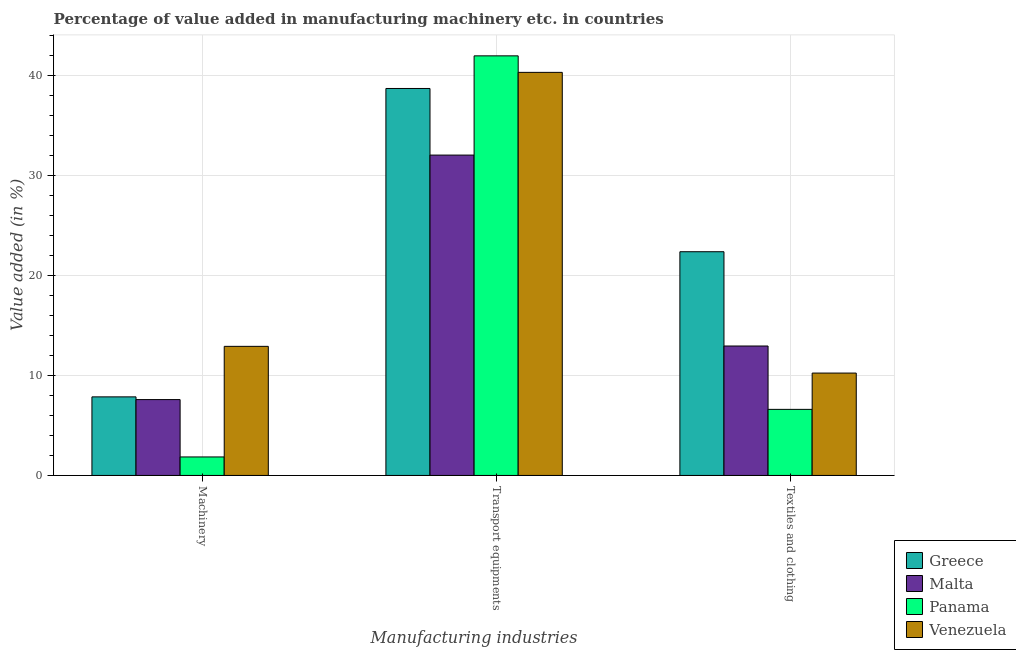How many groups of bars are there?
Keep it short and to the point. 3. Are the number of bars per tick equal to the number of legend labels?
Make the answer very short. Yes. Are the number of bars on each tick of the X-axis equal?
Your answer should be very brief. Yes. How many bars are there on the 3rd tick from the left?
Provide a short and direct response. 4. What is the label of the 2nd group of bars from the left?
Make the answer very short. Transport equipments. What is the value added in manufacturing transport equipments in Malta?
Your answer should be very brief. 32.06. Across all countries, what is the maximum value added in manufacturing machinery?
Your answer should be very brief. 12.92. Across all countries, what is the minimum value added in manufacturing transport equipments?
Give a very brief answer. 32.06. In which country was the value added in manufacturing transport equipments maximum?
Give a very brief answer. Panama. In which country was the value added in manufacturing machinery minimum?
Provide a short and direct response. Panama. What is the total value added in manufacturing machinery in the graph?
Keep it short and to the point. 30.22. What is the difference between the value added in manufacturing textile and clothing in Venezuela and that in Panama?
Give a very brief answer. 3.63. What is the difference between the value added in manufacturing textile and clothing in Venezuela and the value added in manufacturing transport equipments in Panama?
Your answer should be compact. -31.74. What is the average value added in manufacturing textile and clothing per country?
Ensure brevity in your answer.  13.05. What is the difference between the value added in manufacturing textile and clothing and value added in manufacturing transport equipments in Venezuela?
Your answer should be compact. -30.09. In how many countries, is the value added in manufacturing transport equipments greater than 26 %?
Ensure brevity in your answer.  4. What is the ratio of the value added in manufacturing textile and clothing in Greece to that in Venezuela?
Keep it short and to the point. 2.19. What is the difference between the highest and the second highest value added in manufacturing machinery?
Provide a short and direct response. 5.05. What is the difference between the highest and the lowest value added in manufacturing textile and clothing?
Your answer should be very brief. 15.78. What does the 4th bar from the left in Transport equipments represents?
Give a very brief answer. Venezuela. What does the 3rd bar from the right in Transport equipments represents?
Your answer should be compact. Malta. Are the values on the major ticks of Y-axis written in scientific E-notation?
Offer a very short reply. No. Does the graph contain any zero values?
Make the answer very short. No. How are the legend labels stacked?
Your answer should be compact. Vertical. What is the title of the graph?
Offer a terse response. Percentage of value added in manufacturing machinery etc. in countries. Does "Niger" appear as one of the legend labels in the graph?
Offer a terse response. No. What is the label or title of the X-axis?
Ensure brevity in your answer.  Manufacturing industries. What is the label or title of the Y-axis?
Give a very brief answer. Value added (in %). What is the Value added (in %) in Greece in Machinery?
Ensure brevity in your answer.  7.86. What is the Value added (in %) in Malta in Machinery?
Ensure brevity in your answer.  7.59. What is the Value added (in %) in Panama in Machinery?
Your response must be concise. 1.85. What is the Value added (in %) of Venezuela in Machinery?
Your response must be concise. 12.92. What is the Value added (in %) of Greece in Transport equipments?
Keep it short and to the point. 38.72. What is the Value added (in %) in Malta in Transport equipments?
Make the answer very short. 32.06. What is the Value added (in %) of Panama in Transport equipments?
Your response must be concise. 41.99. What is the Value added (in %) in Venezuela in Transport equipments?
Offer a terse response. 40.33. What is the Value added (in %) in Greece in Textiles and clothing?
Your response must be concise. 22.39. What is the Value added (in %) of Malta in Textiles and clothing?
Offer a very short reply. 12.95. What is the Value added (in %) of Panama in Textiles and clothing?
Make the answer very short. 6.61. What is the Value added (in %) of Venezuela in Textiles and clothing?
Your response must be concise. 10.24. Across all Manufacturing industries, what is the maximum Value added (in %) of Greece?
Give a very brief answer. 38.72. Across all Manufacturing industries, what is the maximum Value added (in %) in Malta?
Give a very brief answer. 32.06. Across all Manufacturing industries, what is the maximum Value added (in %) in Panama?
Provide a succinct answer. 41.99. Across all Manufacturing industries, what is the maximum Value added (in %) of Venezuela?
Make the answer very short. 40.33. Across all Manufacturing industries, what is the minimum Value added (in %) in Greece?
Your answer should be compact. 7.86. Across all Manufacturing industries, what is the minimum Value added (in %) of Malta?
Give a very brief answer. 7.59. Across all Manufacturing industries, what is the minimum Value added (in %) in Panama?
Provide a short and direct response. 1.85. Across all Manufacturing industries, what is the minimum Value added (in %) of Venezuela?
Offer a very short reply. 10.24. What is the total Value added (in %) in Greece in the graph?
Offer a very short reply. 68.97. What is the total Value added (in %) in Malta in the graph?
Provide a short and direct response. 52.6. What is the total Value added (in %) in Panama in the graph?
Your answer should be compact. 50.45. What is the total Value added (in %) of Venezuela in the graph?
Make the answer very short. 63.49. What is the difference between the Value added (in %) in Greece in Machinery and that in Transport equipments?
Provide a succinct answer. -30.86. What is the difference between the Value added (in %) in Malta in Machinery and that in Transport equipments?
Give a very brief answer. -24.47. What is the difference between the Value added (in %) in Panama in Machinery and that in Transport equipments?
Offer a terse response. -40.14. What is the difference between the Value added (in %) of Venezuela in Machinery and that in Transport equipments?
Offer a terse response. -27.42. What is the difference between the Value added (in %) of Greece in Machinery and that in Textiles and clothing?
Keep it short and to the point. -14.52. What is the difference between the Value added (in %) of Malta in Machinery and that in Textiles and clothing?
Provide a succinct answer. -5.36. What is the difference between the Value added (in %) of Panama in Machinery and that in Textiles and clothing?
Make the answer very short. -4.76. What is the difference between the Value added (in %) of Venezuela in Machinery and that in Textiles and clothing?
Provide a short and direct response. 2.67. What is the difference between the Value added (in %) of Greece in Transport equipments and that in Textiles and clothing?
Provide a short and direct response. 16.34. What is the difference between the Value added (in %) in Malta in Transport equipments and that in Textiles and clothing?
Your response must be concise. 19.1. What is the difference between the Value added (in %) in Panama in Transport equipments and that in Textiles and clothing?
Provide a succinct answer. 35.38. What is the difference between the Value added (in %) of Venezuela in Transport equipments and that in Textiles and clothing?
Give a very brief answer. 30.09. What is the difference between the Value added (in %) of Greece in Machinery and the Value added (in %) of Malta in Transport equipments?
Make the answer very short. -24.19. What is the difference between the Value added (in %) of Greece in Machinery and the Value added (in %) of Panama in Transport equipments?
Your answer should be very brief. -34.12. What is the difference between the Value added (in %) in Greece in Machinery and the Value added (in %) in Venezuela in Transport equipments?
Provide a succinct answer. -32.47. What is the difference between the Value added (in %) in Malta in Machinery and the Value added (in %) in Panama in Transport equipments?
Your answer should be very brief. -34.4. What is the difference between the Value added (in %) in Malta in Machinery and the Value added (in %) in Venezuela in Transport equipments?
Make the answer very short. -32.74. What is the difference between the Value added (in %) in Panama in Machinery and the Value added (in %) in Venezuela in Transport equipments?
Your answer should be very brief. -38.48. What is the difference between the Value added (in %) in Greece in Machinery and the Value added (in %) in Malta in Textiles and clothing?
Keep it short and to the point. -5.09. What is the difference between the Value added (in %) in Greece in Machinery and the Value added (in %) in Panama in Textiles and clothing?
Your answer should be very brief. 1.25. What is the difference between the Value added (in %) in Greece in Machinery and the Value added (in %) in Venezuela in Textiles and clothing?
Give a very brief answer. -2.38. What is the difference between the Value added (in %) in Malta in Machinery and the Value added (in %) in Panama in Textiles and clothing?
Keep it short and to the point. 0.98. What is the difference between the Value added (in %) in Malta in Machinery and the Value added (in %) in Venezuela in Textiles and clothing?
Your answer should be very brief. -2.65. What is the difference between the Value added (in %) of Panama in Machinery and the Value added (in %) of Venezuela in Textiles and clothing?
Offer a very short reply. -8.39. What is the difference between the Value added (in %) in Greece in Transport equipments and the Value added (in %) in Malta in Textiles and clothing?
Ensure brevity in your answer.  25.77. What is the difference between the Value added (in %) in Greece in Transport equipments and the Value added (in %) in Panama in Textiles and clothing?
Make the answer very short. 32.11. What is the difference between the Value added (in %) in Greece in Transport equipments and the Value added (in %) in Venezuela in Textiles and clothing?
Make the answer very short. 28.48. What is the difference between the Value added (in %) in Malta in Transport equipments and the Value added (in %) in Panama in Textiles and clothing?
Ensure brevity in your answer.  25.45. What is the difference between the Value added (in %) in Malta in Transport equipments and the Value added (in %) in Venezuela in Textiles and clothing?
Keep it short and to the point. 21.81. What is the difference between the Value added (in %) in Panama in Transport equipments and the Value added (in %) in Venezuela in Textiles and clothing?
Ensure brevity in your answer.  31.74. What is the average Value added (in %) in Greece per Manufacturing industries?
Give a very brief answer. 22.99. What is the average Value added (in %) in Malta per Manufacturing industries?
Your response must be concise. 17.53. What is the average Value added (in %) in Panama per Manufacturing industries?
Your response must be concise. 16.82. What is the average Value added (in %) of Venezuela per Manufacturing industries?
Offer a very short reply. 21.16. What is the difference between the Value added (in %) of Greece and Value added (in %) of Malta in Machinery?
Your answer should be compact. 0.27. What is the difference between the Value added (in %) in Greece and Value added (in %) in Panama in Machinery?
Give a very brief answer. 6.01. What is the difference between the Value added (in %) in Greece and Value added (in %) in Venezuela in Machinery?
Make the answer very short. -5.05. What is the difference between the Value added (in %) in Malta and Value added (in %) in Panama in Machinery?
Your response must be concise. 5.74. What is the difference between the Value added (in %) of Malta and Value added (in %) of Venezuela in Machinery?
Ensure brevity in your answer.  -5.33. What is the difference between the Value added (in %) of Panama and Value added (in %) of Venezuela in Machinery?
Offer a very short reply. -11.07. What is the difference between the Value added (in %) of Greece and Value added (in %) of Malta in Transport equipments?
Your answer should be very brief. 6.67. What is the difference between the Value added (in %) in Greece and Value added (in %) in Panama in Transport equipments?
Provide a short and direct response. -3.26. What is the difference between the Value added (in %) of Greece and Value added (in %) of Venezuela in Transport equipments?
Provide a succinct answer. -1.61. What is the difference between the Value added (in %) in Malta and Value added (in %) in Panama in Transport equipments?
Provide a succinct answer. -9.93. What is the difference between the Value added (in %) in Malta and Value added (in %) in Venezuela in Transport equipments?
Keep it short and to the point. -8.28. What is the difference between the Value added (in %) in Panama and Value added (in %) in Venezuela in Transport equipments?
Offer a very short reply. 1.65. What is the difference between the Value added (in %) of Greece and Value added (in %) of Malta in Textiles and clothing?
Offer a very short reply. 9.43. What is the difference between the Value added (in %) of Greece and Value added (in %) of Panama in Textiles and clothing?
Make the answer very short. 15.78. What is the difference between the Value added (in %) of Greece and Value added (in %) of Venezuela in Textiles and clothing?
Give a very brief answer. 12.14. What is the difference between the Value added (in %) in Malta and Value added (in %) in Panama in Textiles and clothing?
Give a very brief answer. 6.34. What is the difference between the Value added (in %) of Malta and Value added (in %) of Venezuela in Textiles and clothing?
Your answer should be compact. 2.71. What is the difference between the Value added (in %) in Panama and Value added (in %) in Venezuela in Textiles and clothing?
Give a very brief answer. -3.63. What is the ratio of the Value added (in %) of Greece in Machinery to that in Transport equipments?
Your answer should be very brief. 0.2. What is the ratio of the Value added (in %) in Malta in Machinery to that in Transport equipments?
Your answer should be compact. 0.24. What is the ratio of the Value added (in %) of Panama in Machinery to that in Transport equipments?
Make the answer very short. 0.04. What is the ratio of the Value added (in %) in Venezuela in Machinery to that in Transport equipments?
Your answer should be very brief. 0.32. What is the ratio of the Value added (in %) of Greece in Machinery to that in Textiles and clothing?
Your answer should be compact. 0.35. What is the ratio of the Value added (in %) of Malta in Machinery to that in Textiles and clothing?
Provide a short and direct response. 0.59. What is the ratio of the Value added (in %) in Panama in Machinery to that in Textiles and clothing?
Offer a very short reply. 0.28. What is the ratio of the Value added (in %) in Venezuela in Machinery to that in Textiles and clothing?
Give a very brief answer. 1.26. What is the ratio of the Value added (in %) in Greece in Transport equipments to that in Textiles and clothing?
Your answer should be very brief. 1.73. What is the ratio of the Value added (in %) of Malta in Transport equipments to that in Textiles and clothing?
Provide a succinct answer. 2.47. What is the ratio of the Value added (in %) of Panama in Transport equipments to that in Textiles and clothing?
Ensure brevity in your answer.  6.35. What is the ratio of the Value added (in %) in Venezuela in Transport equipments to that in Textiles and clothing?
Offer a terse response. 3.94. What is the difference between the highest and the second highest Value added (in %) in Greece?
Offer a very short reply. 16.34. What is the difference between the highest and the second highest Value added (in %) of Malta?
Provide a short and direct response. 19.1. What is the difference between the highest and the second highest Value added (in %) in Panama?
Make the answer very short. 35.38. What is the difference between the highest and the second highest Value added (in %) of Venezuela?
Provide a succinct answer. 27.42. What is the difference between the highest and the lowest Value added (in %) of Greece?
Provide a short and direct response. 30.86. What is the difference between the highest and the lowest Value added (in %) of Malta?
Provide a succinct answer. 24.47. What is the difference between the highest and the lowest Value added (in %) in Panama?
Provide a succinct answer. 40.14. What is the difference between the highest and the lowest Value added (in %) of Venezuela?
Provide a succinct answer. 30.09. 